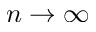<formula> <loc_0><loc_0><loc_500><loc_500>n \rightarrow \infty</formula> 